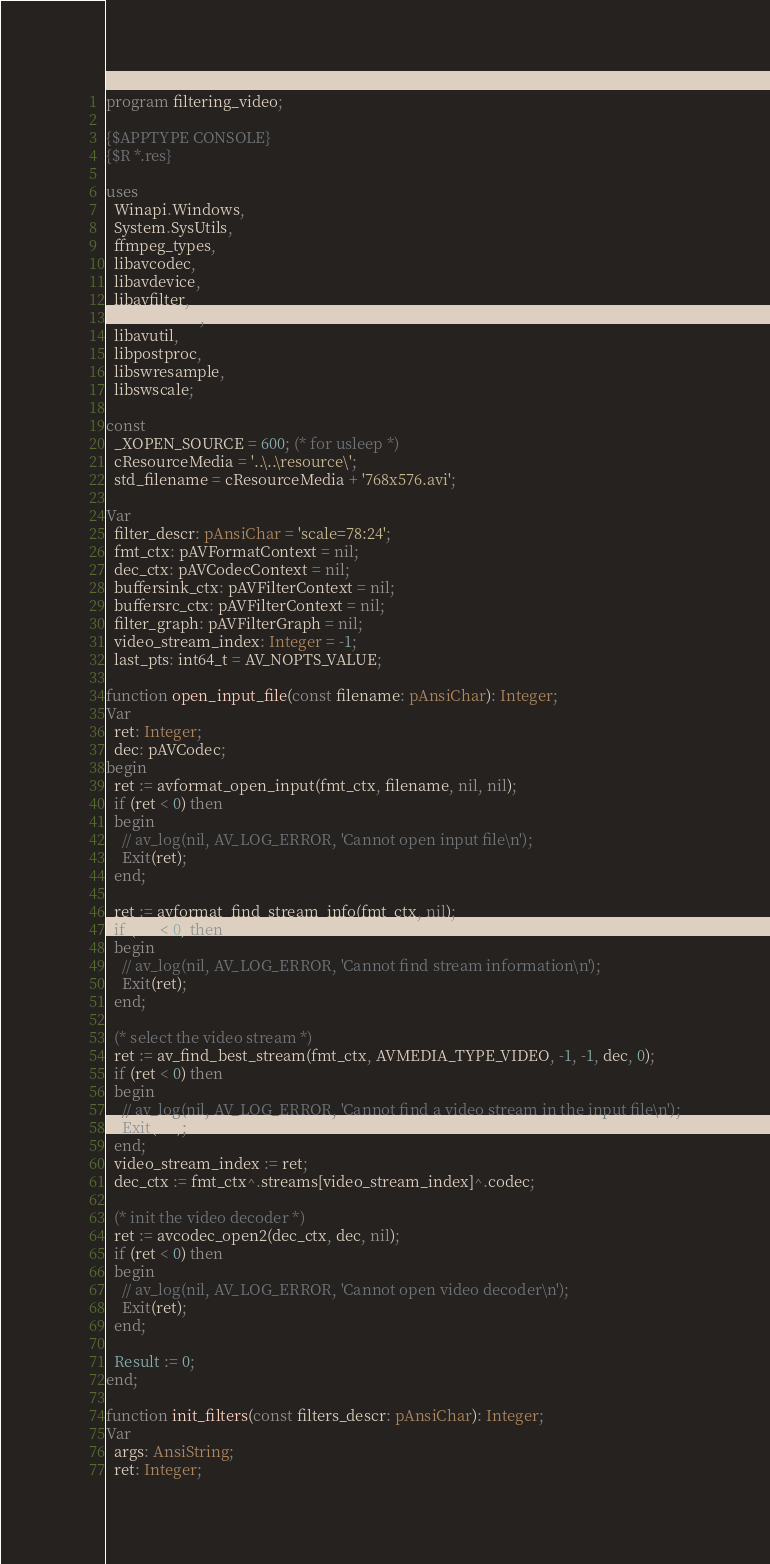Convert code to text. <code><loc_0><loc_0><loc_500><loc_500><_Pascal_>program filtering_video;

{$APPTYPE CONSOLE}
{$R *.res}

uses
  Winapi.Windows,
  System.SysUtils,
  ffmpeg_types,
  libavcodec,
  libavdevice,
  libavfilter,
  libavformat,
  libavutil,
  libpostproc,
  libswresample,
  libswscale;

const
  _XOPEN_SOURCE = 600; (* for usleep *)
  cResourceMedia = '..\..\resource\';
  std_filename = cResourceMedia + '768x576.avi';

Var
  filter_descr: pAnsiChar = 'scale=78:24';
  fmt_ctx: pAVFormatContext = nil;
  dec_ctx: pAVCodecContext = nil;
  buffersink_ctx: pAVFilterContext = nil;
  buffersrc_ctx: pAVFilterContext = nil;
  filter_graph: pAVFilterGraph = nil;
  video_stream_index: Integer = -1;
  last_pts: int64_t = AV_NOPTS_VALUE;

function open_input_file(const filename: pAnsiChar): Integer;
Var
  ret: Integer;
  dec: pAVCodec;
begin
  ret := avformat_open_input(fmt_ctx, filename, nil, nil);
  if (ret < 0) then
  begin
    // av_log(nil, AV_LOG_ERROR, 'Cannot open input file\n');
    Exit(ret);
  end;

  ret := avformat_find_stream_info(fmt_ctx, nil);
  if (ret < 0) then
  begin
    // av_log(nil, AV_LOG_ERROR, 'Cannot find stream information\n');
    Exit(ret);
  end;

  (* select the video stream *)
  ret := av_find_best_stream(fmt_ctx, AVMEDIA_TYPE_VIDEO, -1, -1, dec, 0);
  if (ret < 0) then
  begin
    // av_log(nil, AV_LOG_ERROR, 'Cannot find a video stream in the input file\n');
    Exit(ret);
  end;
  video_stream_index := ret;
  dec_ctx := fmt_ctx^.streams[video_stream_index]^.codec;

  (* init the video decoder *)
  ret := avcodec_open2(dec_ctx, dec, nil);
  if (ret < 0) then
  begin
    // av_log(nil, AV_LOG_ERROR, 'Cannot open video decoder\n');
    Exit(ret);
  end;

  Result := 0;
end;

function init_filters(const filters_descr: pAnsiChar): Integer;
Var
  args: AnsiString;
  ret: Integer;</code> 